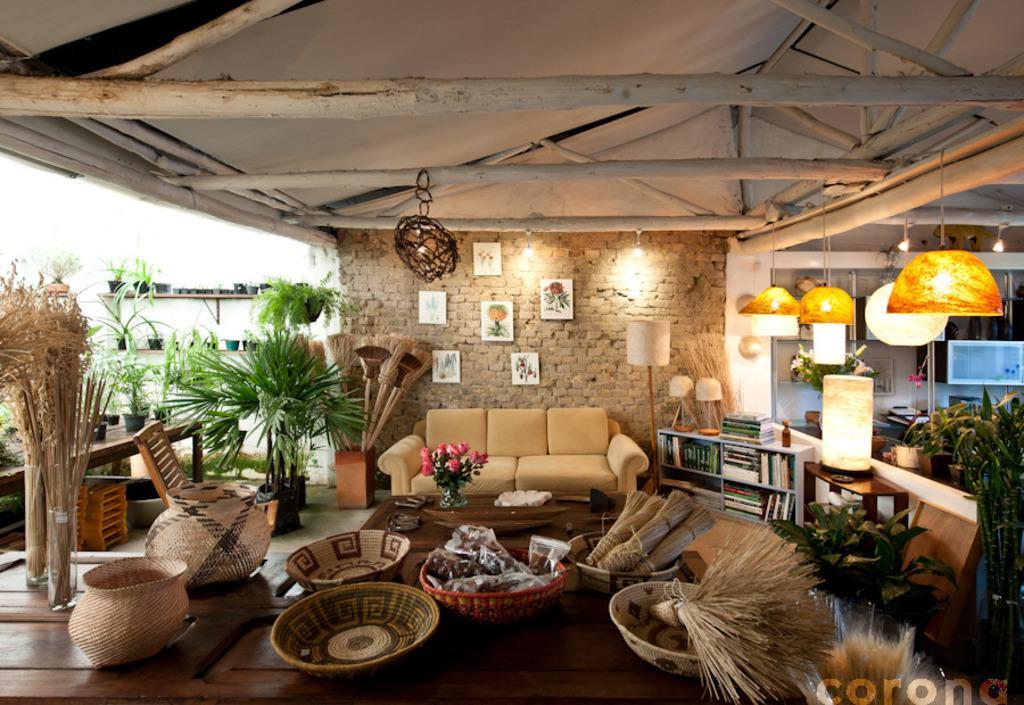Please provide a concise description of this image. In this picture we can see there are some bowls and objects on the table and behind the table there is another table and on the table there is a flower vase and some items. Behind the tables there is a couch and on the right side of the couch there are books in and on the shelves. At the top there are lights. Behind the couch there's a wall with photo frames. On the left side of the couch there are house plants and a chair and some plants and on the table. On the image there is a watermark. 